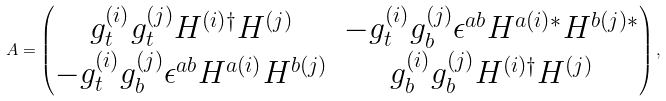Convert formula to latex. <formula><loc_0><loc_0><loc_500><loc_500>A = \begin{pmatrix} g _ { t } ^ { ( i ) } g _ { t } ^ { ( j ) } H ^ { ( i ) \dagger } H ^ { ( j ) } & - g _ { t } ^ { ( i ) } g _ { b } ^ { ( j ) } \epsilon ^ { a b } H ^ { a ( i ) * } H ^ { b ( j ) * } \\ - g _ { t } ^ { ( i ) } g _ { b } ^ { ( j ) } \epsilon ^ { a b } H ^ { a ( i ) } H ^ { b ( j ) } & g _ { b } ^ { ( i ) } g _ { b } ^ { ( j ) } H ^ { ( i ) \dagger } H ^ { ( j ) } \end{pmatrix} ,</formula> 